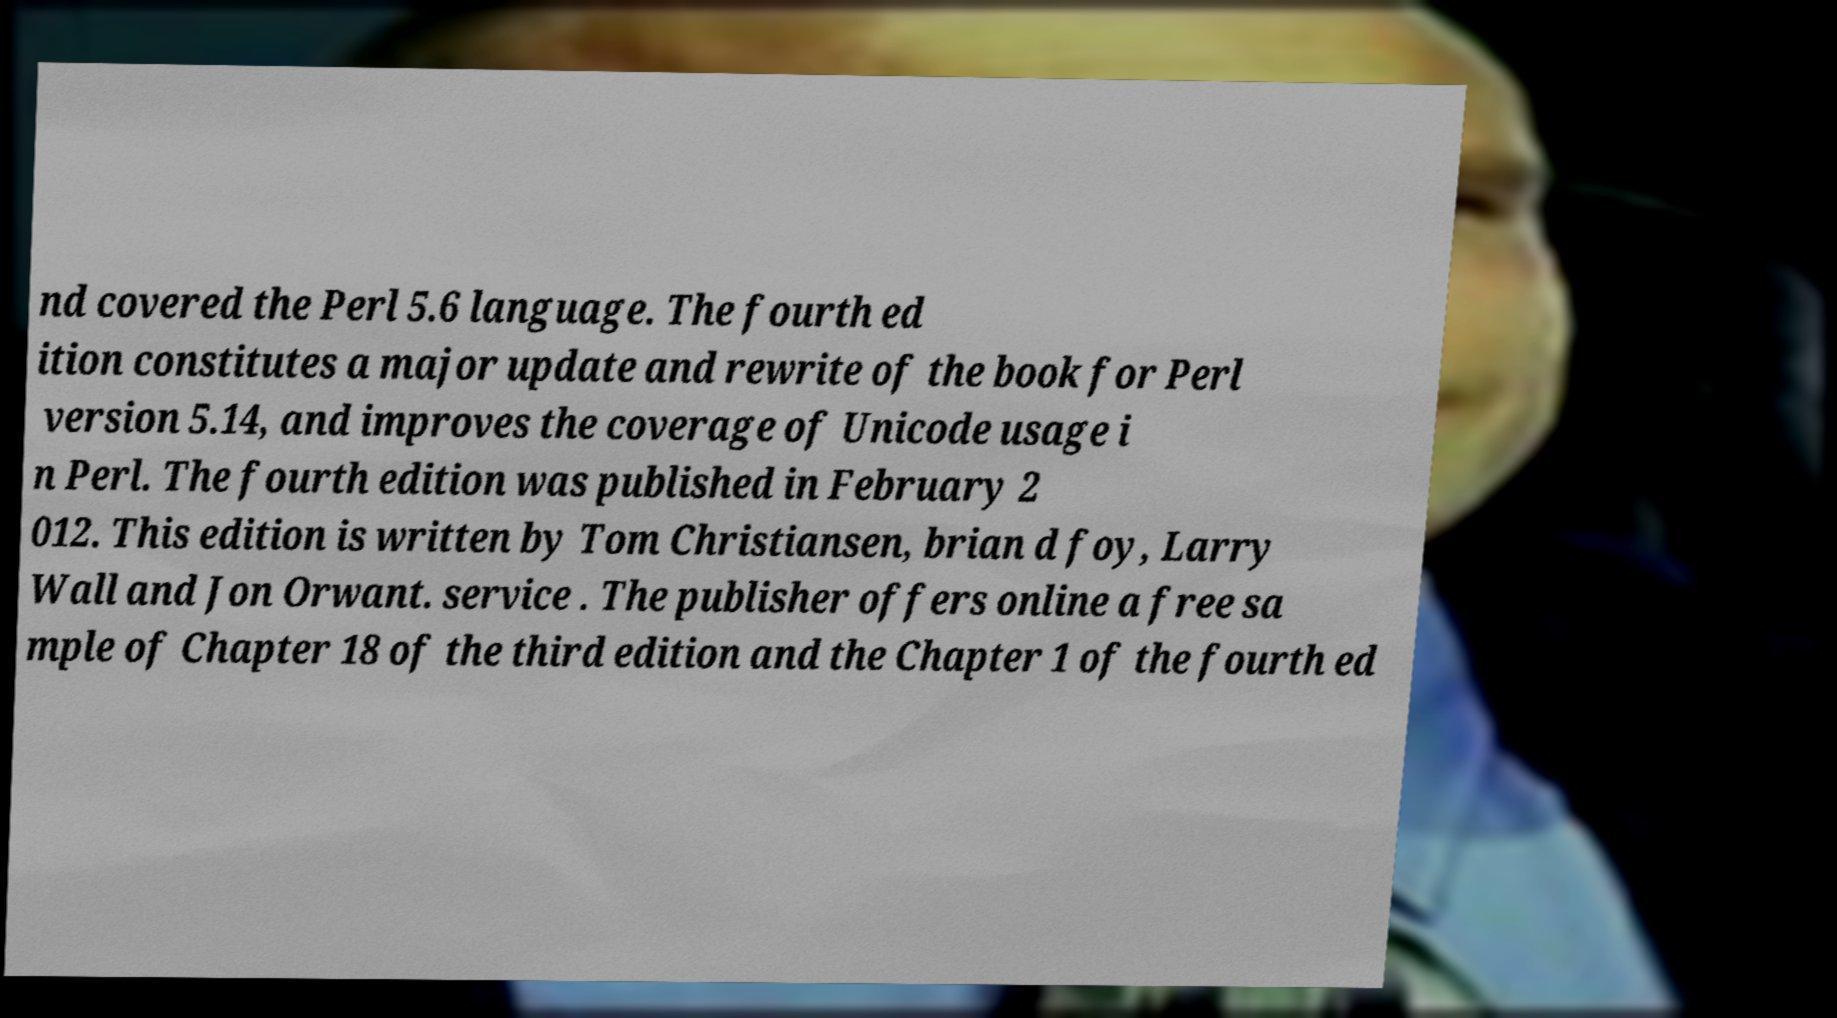There's text embedded in this image that I need extracted. Can you transcribe it verbatim? nd covered the Perl 5.6 language. The fourth ed ition constitutes a major update and rewrite of the book for Perl version 5.14, and improves the coverage of Unicode usage i n Perl. The fourth edition was published in February 2 012. This edition is written by Tom Christiansen, brian d foy, Larry Wall and Jon Orwant. service . The publisher offers online a free sa mple of Chapter 18 of the third edition and the Chapter 1 of the fourth ed 